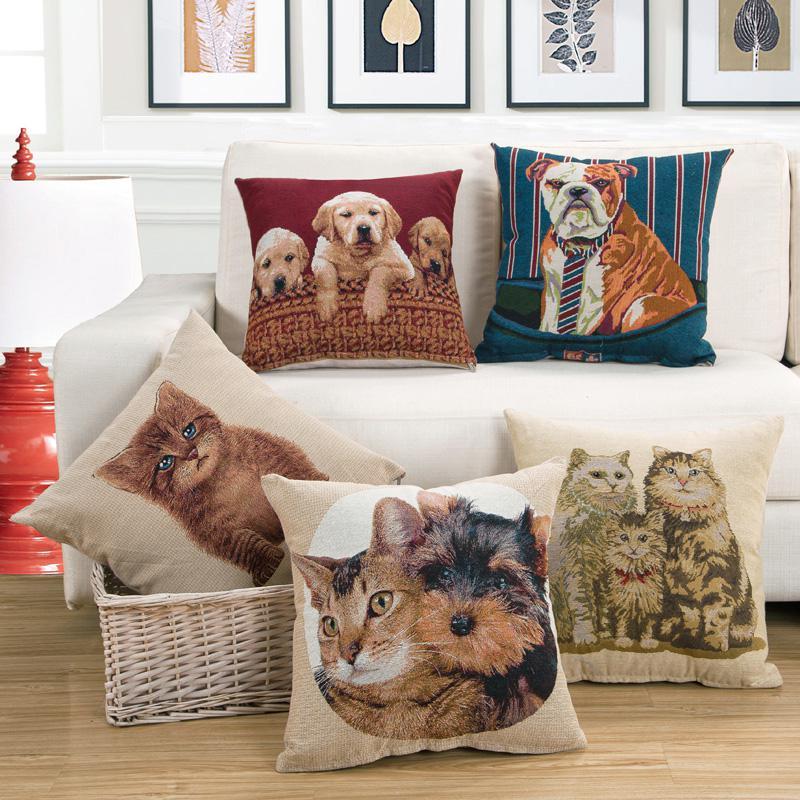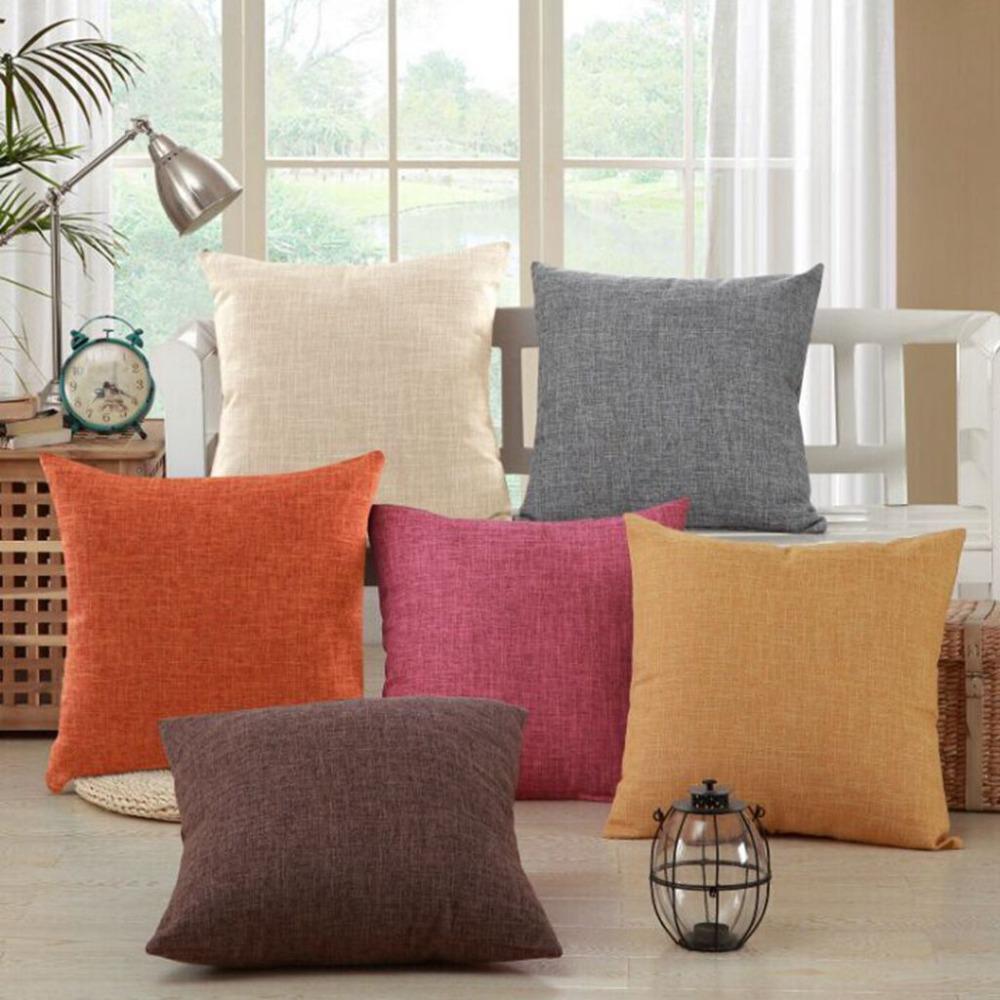The first image is the image on the left, the second image is the image on the right. Evaluate the accuracy of this statement regarding the images: "Flowers in a vase are visible in the image on the right.". Is it true? Answer yes or no. No. 